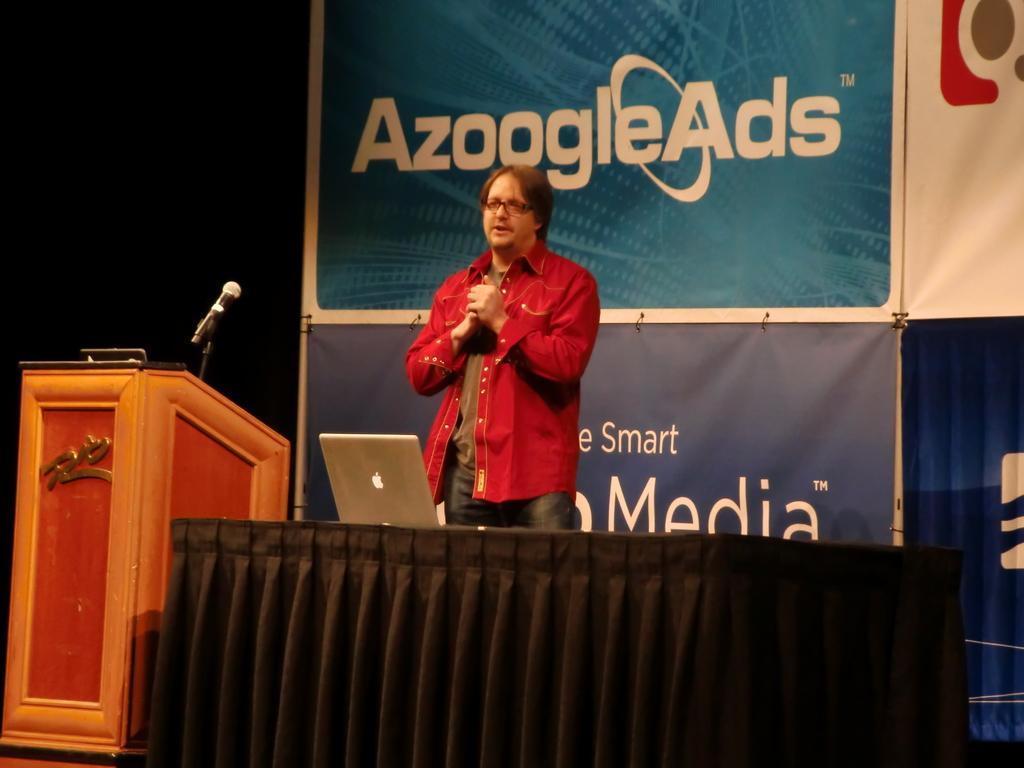Can you describe this image briefly? In this image I can see a person standing. In front of him there is a laptop on a table and to the left of the image there is a podium with a mic. Behind the person there are some banners with text on it. 